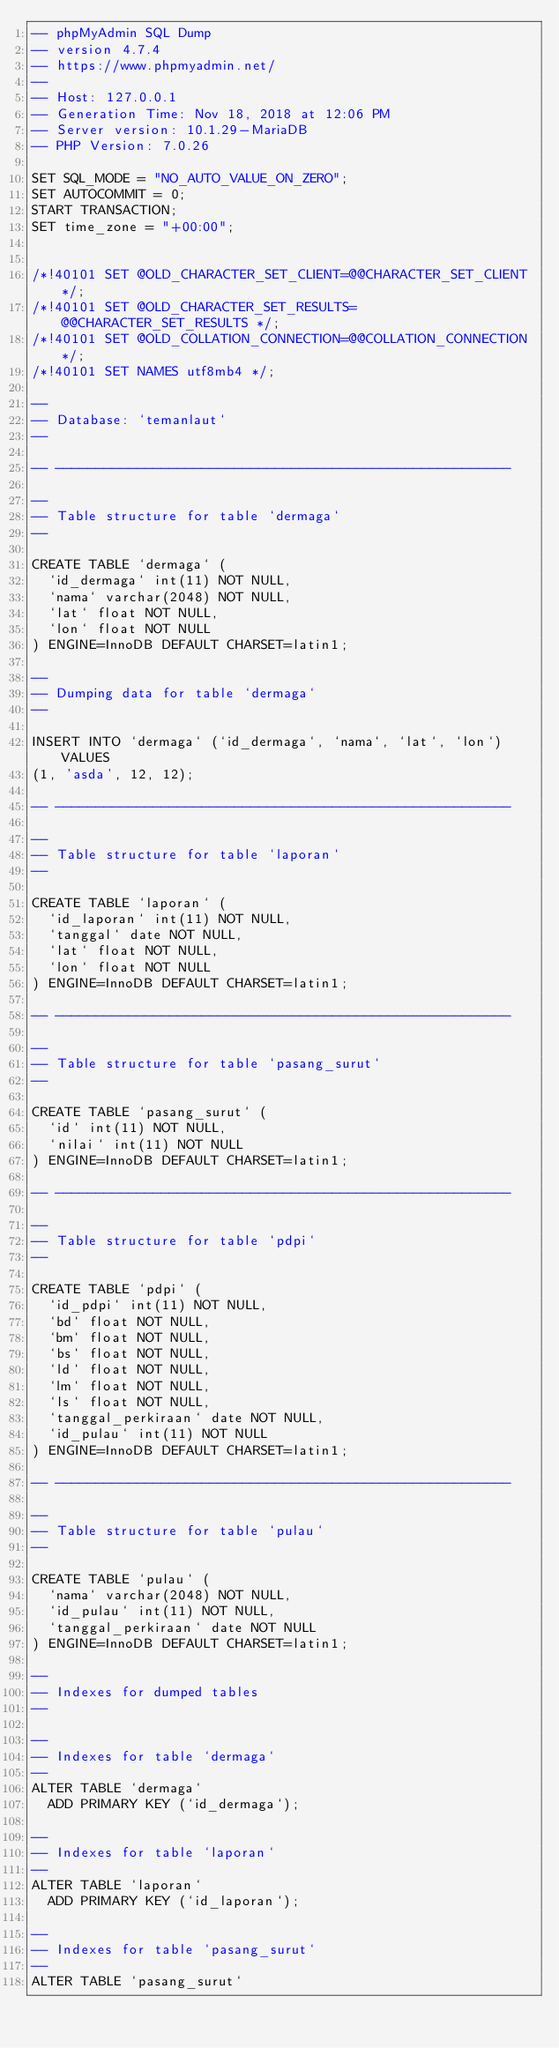<code> <loc_0><loc_0><loc_500><loc_500><_SQL_>-- phpMyAdmin SQL Dump
-- version 4.7.4
-- https://www.phpmyadmin.net/
--
-- Host: 127.0.0.1
-- Generation Time: Nov 18, 2018 at 12:06 PM
-- Server version: 10.1.29-MariaDB
-- PHP Version: 7.0.26

SET SQL_MODE = "NO_AUTO_VALUE_ON_ZERO";
SET AUTOCOMMIT = 0;
START TRANSACTION;
SET time_zone = "+00:00";


/*!40101 SET @OLD_CHARACTER_SET_CLIENT=@@CHARACTER_SET_CLIENT */;
/*!40101 SET @OLD_CHARACTER_SET_RESULTS=@@CHARACTER_SET_RESULTS */;
/*!40101 SET @OLD_COLLATION_CONNECTION=@@COLLATION_CONNECTION */;
/*!40101 SET NAMES utf8mb4 */;

--
-- Database: `temanlaut`
--

-- --------------------------------------------------------

--
-- Table structure for table `dermaga`
--

CREATE TABLE `dermaga` (
  `id_dermaga` int(11) NOT NULL,
  `nama` varchar(2048) NOT NULL,
  `lat` float NOT NULL,
  `lon` float NOT NULL
) ENGINE=InnoDB DEFAULT CHARSET=latin1;

--
-- Dumping data for table `dermaga`
--

INSERT INTO `dermaga` (`id_dermaga`, `nama`, `lat`, `lon`) VALUES
(1, 'asda', 12, 12);

-- --------------------------------------------------------

--
-- Table structure for table `laporan`
--

CREATE TABLE `laporan` (
  `id_laporan` int(11) NOT NULL,
  `tanggal` date NOT NULL,
  `lat` float NOT NULL,
  `lon` float NOT NULL
) ENGINE=InnoDB DEFAULT CHARSET=latin1;

-- --------------------------------------------------------

--
-- Table structure for table `pasang_surut`
--

CREATE TABLE `pasang_surut` (
  `id` int(11) NOT NULL,
  `nilai` int(11) NOT NULL
) ENGINE=InnoDB DEFAULT CHARSET=latin1;

-- --------------------------------------------------------

--
-- Table structure for table `pdpi`
--

CREATE TABLE `pdpi` (
  `id_pdpi` int(11) NOT NULL,
  `bd` float NOT NULL,
  `bm` float NOT NULL,
  `bs` float NOT NULL,
  `ld` float NOT NULL,
  `lm` float NOT NULL,
  `ls` float NOT NULL,
  `tanggal_perkiraan` date NOT NULL,
  `id_pulau` int(11) NOT NULL
) ENGINE=InnoDB DEFAULT CHARSET=latin1;

-- --------------------------------------------------------

--
-- Table structure for table `pulau`
--

CREATE TABLE `pulau` (
  `nama` varchar(2048) NOT NULL,
  `id_pulau` int(11) NOT NULL,
  `tanggal_perkiraan` date NOT NULL
) ENGINE=InnoDB DEFAULT CHARSET=latin1;

--
-- Indexes for dumped tables
--

--
-- Indexes for table `dermaga`
--
ALTER TABLE `dermaga`
  ADD PRIMARY KEY (`id_dermaga`);

--
-- Indexes for table `laporan`
--
ALTER TABLE `laporan`
  ADD PRIMARY KEY (`id_laporan`);

--
-- Indexes for table `pasang_surut`
--
ALTER TABLE `pasang_surut`</code> 